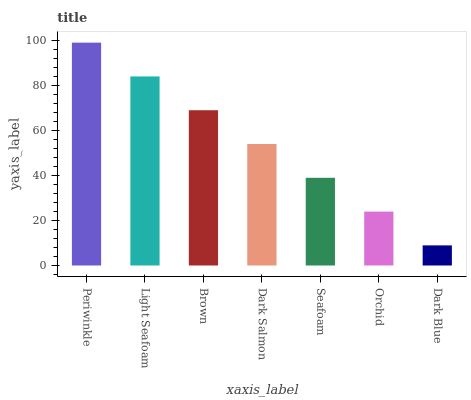Is Dark Blue the minimum?
Answer yes or no. Yes. Is Periwinkle the maximum?
Answer yes or no. Yes. Is Light Seafoam the minimum?
Answer yes or no. No. Is Light Seafoam the maximum?
Answer yes or no. No. Is Periwinkle greater than Light Seafoam?
Answer yes or no. Yes. Is Light Seafoam less than Periwinkle?
Answer yes or no. Yes. Is Light Seafoam greater than Periwinkle?
Answer yes or no. No. Is Periwinkle less than Light Seafoam?
Answer yes or no. No. Is Dark Salmon the high median?
Answer yes or no. Yes. Is Dark Salmon the low median?
Answer yes or no. Yes. Is Dark Blue the high median?
Answer yes or no. No. Is Orchid the low median?
Answer yes or no. No. 